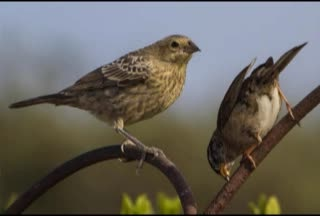Describe the objects in this image and their specific colors. I can see bird in black and gray tones and bird in black, maroon, and gray tones in this image. 